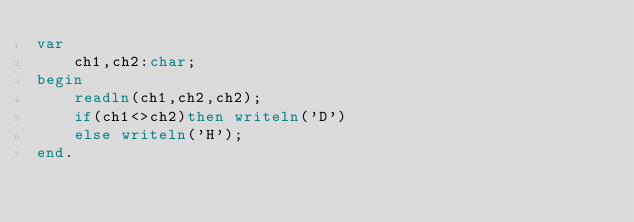<code> <loc_0><loc_0><loc_500><loc_500><_Pascal_>var
    ch1,ch2:char;
begin
    readln(ch1,ch2,ch2);
    if(ch1<>ch2)then writeln('D')
    else writeln('H');
end.
</code> 